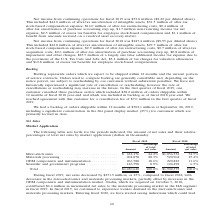According to Coherent's financial document, What is the change in net sales in 2019? decreased by $471.9 million. The document states: "During fiscal 2019, net sales decreased by $471.9 million, or 25%, compared to fiscal 2018, with decreases in the microelectronics and materials proce..." Also, What is the amount of Microelectronics in 2019? According to the financial document, $632,176 (in thousands). The relevant text states: "Microelectronics . $ 632,176 44.2% $1,036,354 54.5% Materials processing . 404,878 28.3% 520,904 27.4% OEM components and instru..." Also, In which years is net sales calculated? The document shows two values: 2019 and 2018. From the document: "Fiscal 2019 Fiscal 2018 Percentage Percentage of total of total Amount net sales Amount net sales Fiscal 2019 Fiscal 2018 Percentage Percentage of tot..." Additionally, In which year was Materials processing a larger percentage of total net sales? According to the financial document, 2019. The relevant text states: "Fiscal 2019 Fiscal 2018 Percentage Percentage of total of total Amount net sales Amount net sales..." Also, can you calculate: What was the change in the amount of OEM components and instrumentation in 2019 from 2018? Based on the calculation: 266,788-220,823, the result is 45965 (in thousands). This is based on the information: "EM components and instrumentation . 266,788 18.6% 220,823 11.6% Scientific and government programs . 126,798 8.9% 124,492 6.5% 20,904 27.4% OEM components and instrumentation . 266,788 18.6% 220,823 1..." The key data points involved are: 220,823, 266,788. Also, can you calculate: What was the percentage change in the amount of OEM components and instrumentation in 2019 from 2018? To answer this question, I need to perform calculations using the financial data. The calculation is: (266,788-220,823)/220,823, which equals 20.82 (percentage). This is based on the information: "EM components and instrumentation . 266,788 18.6% 220,823 11.6% Scientific and government programs . 126,798 8.9% 124,492 6.5% 20,904 27.4% OEM components and instrumentation . 266,788 18.6% 220,823 1..." The key data points involved are: 220,823, 266,788. 